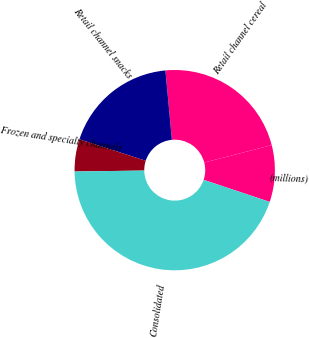<chart> <loc_0><loc_0><loc_500><loc_500><pie_chart><fcel>(millions)<fcel>Retail channel cereal<fcel>Retail channel snacks<fcel>Frozen and specialty channels<fcel>Consolidated<nl><fcel>9.15%<fcel>22.47%<fcel>18.53%<fcel>5.2%<fcel>44.65%<nl></chart> 